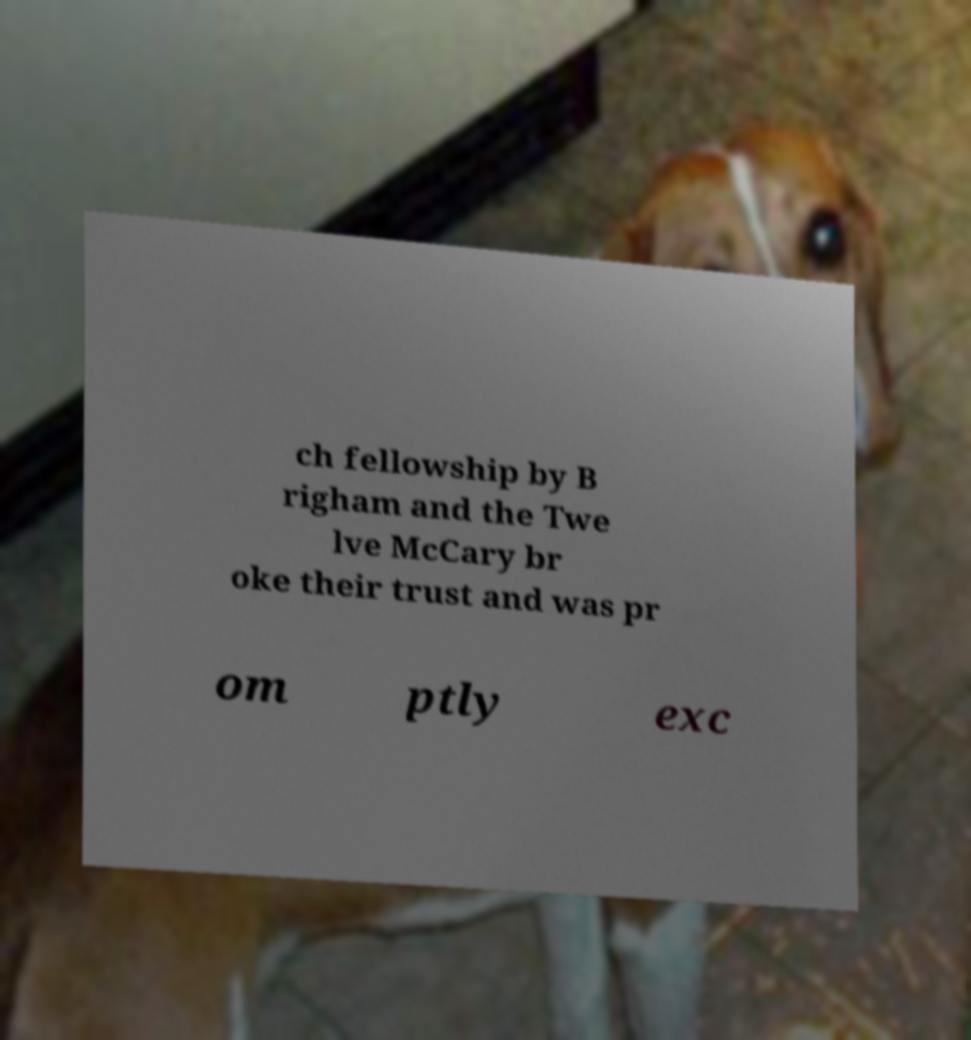Could you extract and type out the text from this image? ch fellowship by B righam and the Twe lve McCary br oke their trust and was pr om ptly exc 